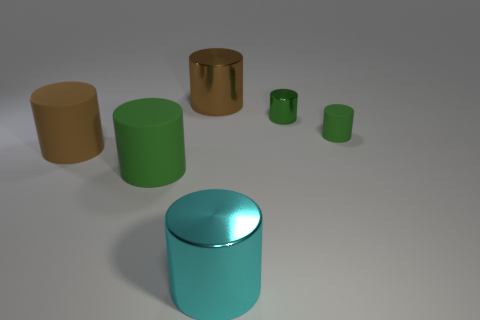Subtract all big brown matte cylinders. How many cylinders are left? 5 Add 3 brown matte cylinders. How many objects exist? 9 Subtract all brown cylinders. How many cylinders are left? 4 Subtract 2 cylinders. How many cylinders are left? 4 Subtract all blue cylinders. Subtract all purple balls. How many cylinders are left? 6 Subtract all gray spheres. How many brown cylinders are left? 2 Subtract all big green rubber cylinders. Subtract all big brown rubber things. How many objects are left? 4 Add 2 green things. How many green things are left? 5 Add 2 large brown cylinders. How many large brown cylinders exist? 4 Subtract 0 red blocks. How many objects are left? 6 